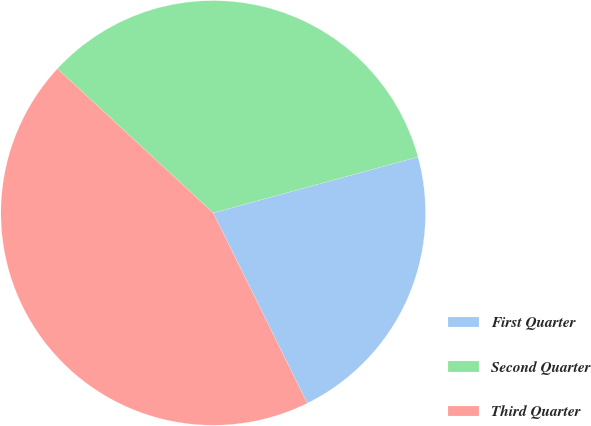<chart> <loc_0><loc_0><loc_500><loc_500><pie_chart><fcel>First Quarter<fcel>Second Quarter<fcel>Third Quarter<nl><fcel>21.94%<fcel>33.86%<fcel>44.2%<nl></chart> 